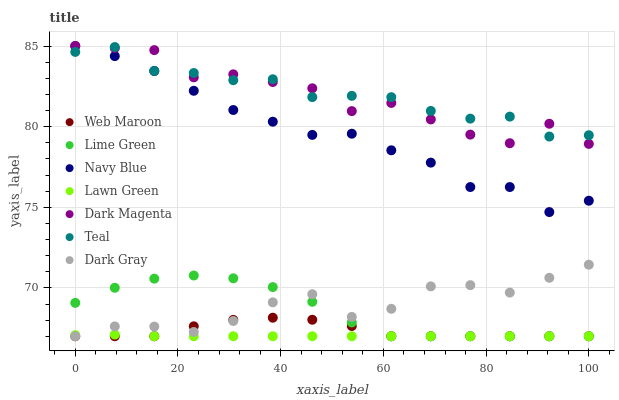Does Lawn Green have the minimum area under the curve?
Answer yes or no. Yes. Does Teal have the maximum area under the curve?
Answer yes or no. Yes. Does Dark Magenta have the minimum area under the curve?
Answer yes or no. No. Does Dark Magenta have the maximum area under the curve?
Answer yes or no. No. Is Lawn Green the smoothest?
Answer yes or no. Yes. Is Dark Magenta the roughest?
Answer yes or no. Yes. Is Navy Blue the smoothest?
Answer yes or no. No. Is Navy Blue the roughest?
Answer yes or no. No. Does Lawn Green have the lowest value?
Answer yes or no. Yes. Does Dark Magenta have the lowest value?
Answer yes or no. No. Does Navy Blue have the highest value?
Answer yes or no. Yes. Does Web Maroon have the highest value?
Answer yes or no. No. Is Lime Green less than Dark Magenta?
Answer yes or no. Yes. Is Navy Blue greater than Lawn Green?
Answer yes or no. Yes. Does Dark Gray intersect Lime Green?
Answer yes or no. Yes. Is Dark Gray less than Lime Green?
Answer yes or no. No. Is Dark Gray greater than Lime Green?
Answer yes or no. No. Does Lime Green intersect Dark Magenta?
Answer yes or no. No. 